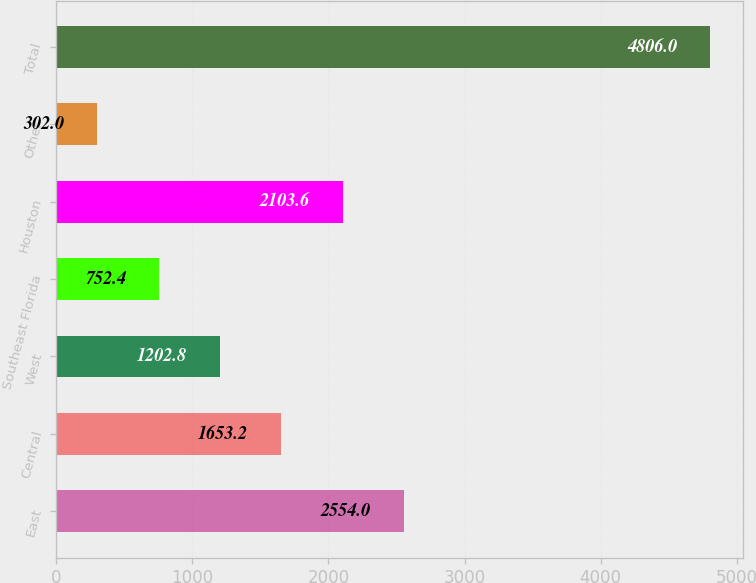Convert chart to OTSL. <chart><loc_0><loc_0><loc_500><loc_500><bar_chart><fcel>East<fcel>Central<fcel>West<fcel>Southeast Florida<fcel>Houston<fcel>Other<fcel>Total<nl><fcel>2554<fcel>1653.2<fcel>1202.8<fcel>752.4<fcel>2103.6<fcel>302<fcel>4806<nl></chart> 